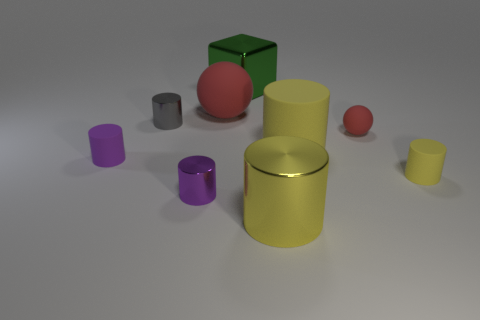There is another red thing that is the same shape as the large red thing; what size is it?
Give a very brief answer. Small. Are there an equal number of big red matte balls that are to the left of the green block and small purple metal cylinders to the right of the yellow metallic thing?
Your answer should be compact. No. How many other things are the same material as the big green block?
Provide a short and direct response. 3. Is the number of small matte things behind the small yellow object the same as the number of yellow matte cylinders?
Keep it short and to the point. Yes. Does the gray cylinder have the same size as the metal object that is behind the big red matte sphere?
Provide a short and direct response. No. What is the shape of the big metal object to the right of the green metal object?
Offer a terse response. Cylinder. Are there any other things that are the same shape as the purple metallic object?
Your response must be concise. Yes. Are any big red matte objects visible?
Offer a very short reply. Yes. There is a matte object that is to the right of the tiny red ball; is its size the same as the yellow cylinder behind the purple rubber cylinder?
Provide a succinct answer. No. There is a cylinder that is to the right of the small gray cylinder and to the left of the metal block; what is it made of?
Ensure brevity in your answer.  Metal. 